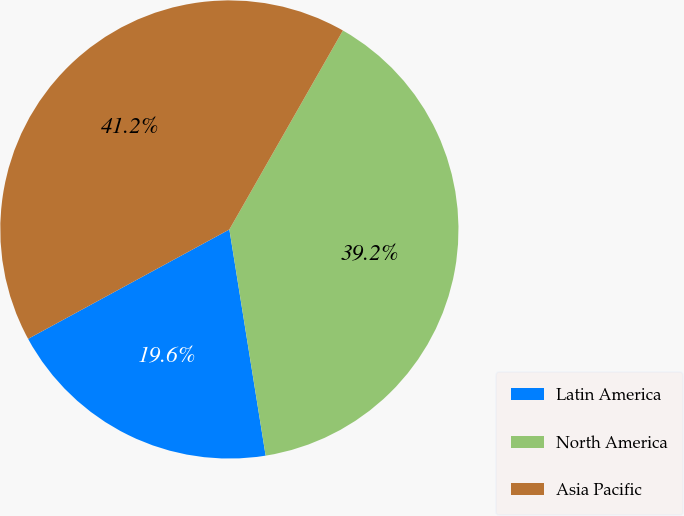Convert chart. <chart><loc_0><loc_0><loc_500><loc_500><pie_chart><fcel>Latin America<fcel>North America<fcel>Asia Pacific<nl><fcel>19.61%<fcel>39.22%<fcel>41.18%<nl></chart> 